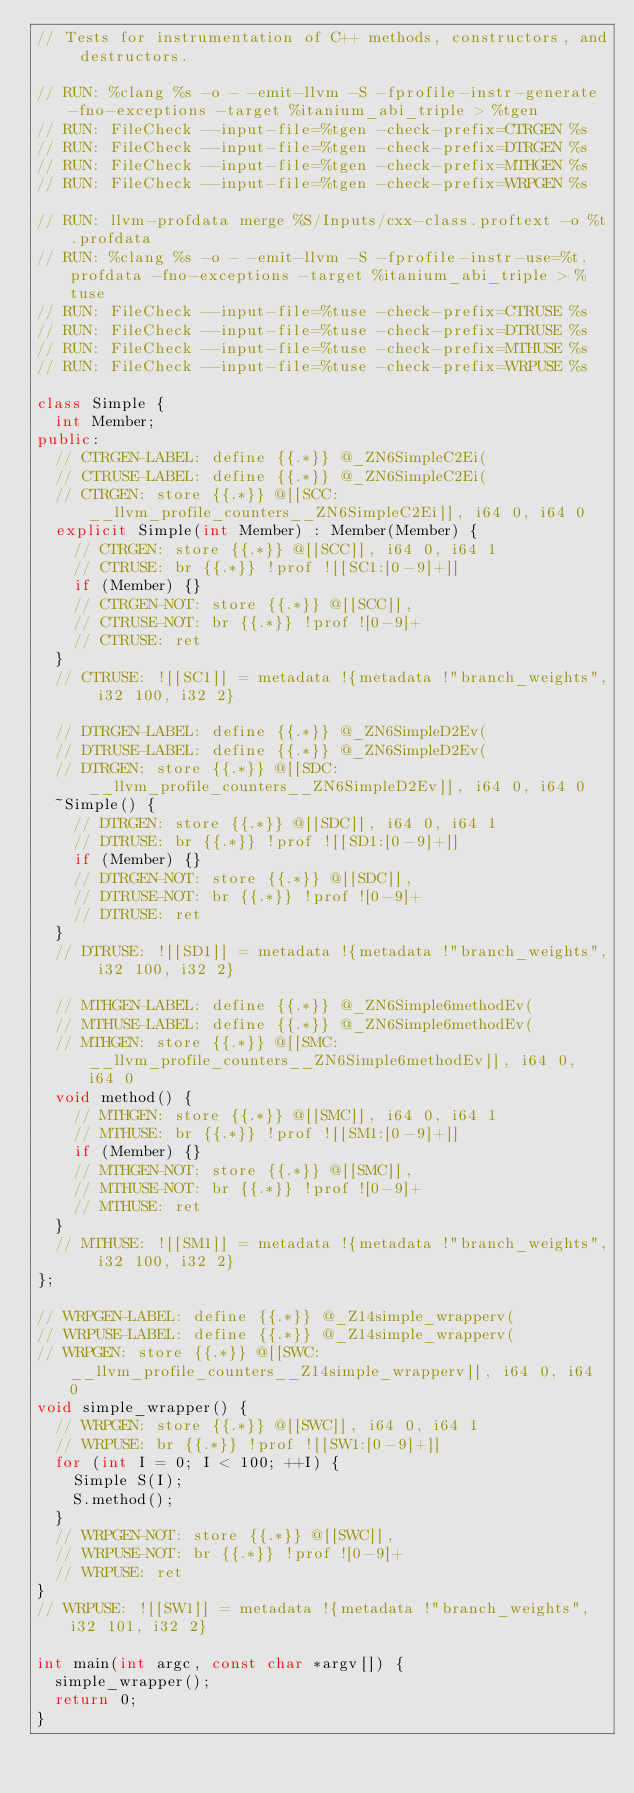Convert code to text. <code><loc_0><loc_0><loc_500><loc_500><_C++_>// Tests for instrumentation of C++ methods, constructors, and destructors.

// RUN: %clang %s -o - -emit-llvm -S -fprofile-instr-generate -fno-exceptions -target %itanium_abi_triple > %tgen
// RUN: FileCheck --input-file=%tgen -check-prefix=CTRGEN %s
// RUN: FileCheck --input-file=%tgen -check-prefix=DTRGEN %s
// RUN: FileCheck --input-file=%tgen -check-prefix=MTHGEN %s
// RUN: FileCheck --input-file=%tgen -check-prefix=WRPGEN %s

// RUN: llvm-profdata merge %S/Inputs/cxx-class.proftext -o %t.profdata
// RUN: %clang %s -o - -emit-llvm -S -fprofile-instr-use=%t.profdata -fno-exceptions -target %itanium_abi_triple > %tuse
// RUN: FileCheck --input-file=%tuse -check-prefix=CTRUSE %s
// RUN: FileCheck --input-file=%tuse -check-prefix=DTRUSE %s
// RUN: FileCheck --input-file=%tuse -check-prefix=MTHUSE %s
// RUN: FileCheck --input-file=%tuse -check-prefix=WRPUSE %s

class Simple {
  int Member;
public:
  // CTRGEN-LABEL: define {{.*}} @_ZN6SimpleC2Ei(
  // CTRUSE-LABEL: define {{.*}} @_ZN6SimpleC2Ei(
  // CTRGEN: store {{.*}} @[[SCC:__llvm_profile_counters__ZN6SimpleC2Ei]], i64 0, i64 0
  explicit Simple(int Member) : Member(Member) {
    // CTRGEN: store {{.*}} @[[SCC]], i64 0, i64 1
    // CTRUSE: br {{.*}} !prof ![[SC1:[0-9]+]]
    if (Member) {}
    // CTRGEN-NOT: store {{.*}} @[[SCC]],
    // CTRUSE-NOT: br {{.*}} !prof ![0-9]+
    // CTRUSE: ret
  }
  // CTRUSE: ![[SC1]] = metadata !{metadata !"branch_weights", i32 100, i32 2}

  // DTRGEN-LABEL: define {{.*}} @_ZN6SimpleD2Ev(
  // DTRUSE-LABEL: define {{.*}} @_ZN6SimpleD2Ev(
  // DTRGEN: store {{.*}} @[[SDC:__llvm_profile_counters__ZN6SimpleD2Ev]], i64 0, i64 0
  ~Simple() {
    // DTRGEN: store {{.*}} @[[SDC]], i64 0, i64 1
    // DTRUSE: br {{.*}} !prof ![[SD1:[0-9]+]]
    if (Member) {}
    // DTRGEN-NOT: store {{.*}} @[[SDC]],
    // DTRUSE-NOT: br {{.*}} !prof ![0-9]+
    // DTRUSE: ret
  }
  // DTRUSE: ![[SD1]] = metadata !{metadata !"branch_weights", i32 100, i32 2}

  // MTHGEN-LABEL: define {{.*}} @_ZN6Simple6methodEv(
  // MTHUSE-LABEL: define {{.*}} @_ZN6Simple6methodEv(
  // MTHGEN: store {{.*}} @[[SMC:__llvm_profile_counters__ZN6Simple6methodEv]], i64 0, i64 0
  void method() {
    // MTHGEN: store {{.*}} @[[SMC]], i64 0, i64 1
    // MTHUSE: br {{.*}} !prof ![[SM1:[0-9]+]]
    if (Member) {}
    // MTHGEN-NOT: store {{.*}} @[[SMC]],
    // MTHUSE-NOT: br {{.*}} !prof ![0-9]+
    // MTHUSE: ret
  }
  // MTHUSE: ![[SM1]] = metadata !{metadata !"branch_weights", i32 100, i32 2}
};

// WRPGEN-LABEL: define {{.*}} @_Z14simple_wrapperv(
// WRPUSE-LABEL: define {{.*}} @_Z14simple_wrapperv(
// WRPGEN: store {{.*}} @[[SWC:__llvm_profile_counters__Z14simple_wrapperv]], i64 0, i64 0
void simple_wrapper() {
  // WRPGEN: store {{.*}} @[[SWC]], i64 0, i64 1
  // WRPUSE: br {{.*}} !prof ![[SW1:[0-9]+]]
  for (int I = 0; I < 100; ++I) {
    Simple S(I);
    S.method();
  }
  // WRPGEN-NOT: store {{.*}} @[[SWC]],
  // WRPUSE-NOT: br {{.*}} !prof ![0-9]+
  // WRPUSE: ret
}
// WRPUSE: ![[SW1]] = metadata !{metadata !"branch_weights", i32 101, i32 2}

int main(int argc, const char *argv[]) {
  simple_wrapper();
  return 0;
}
</code> 